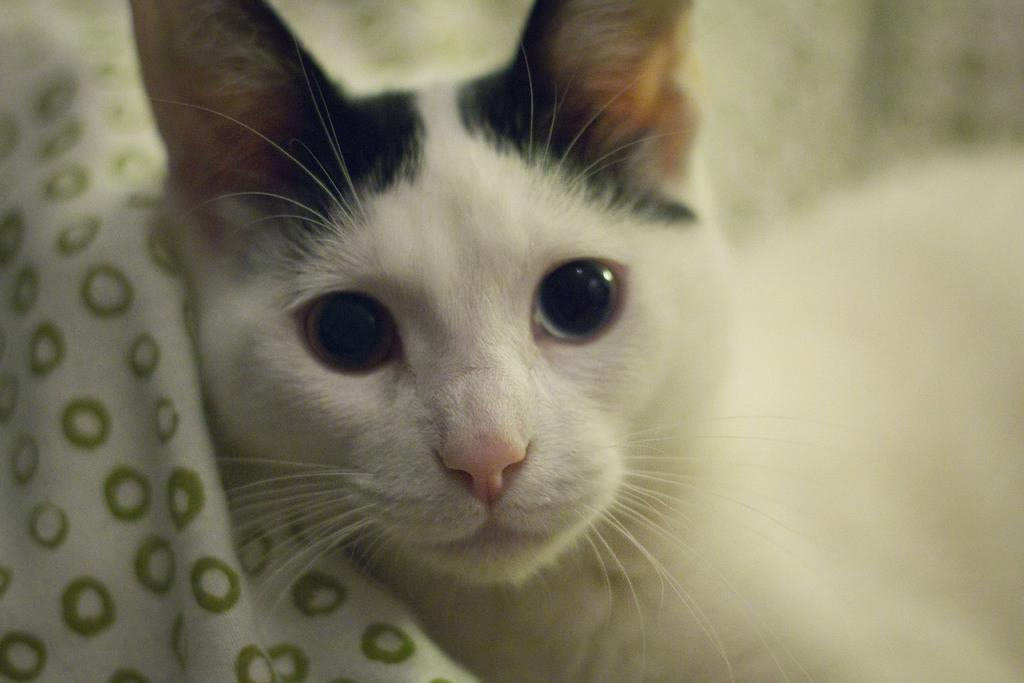What type of animal is present in the image? There is a cat in the image. What other object can be seen in the image? There is a cloth in the image. What type of sticks are being used to treat the disease in the image? There is no mention of sticks or disease in the image; it only features a cat and a cloth. 